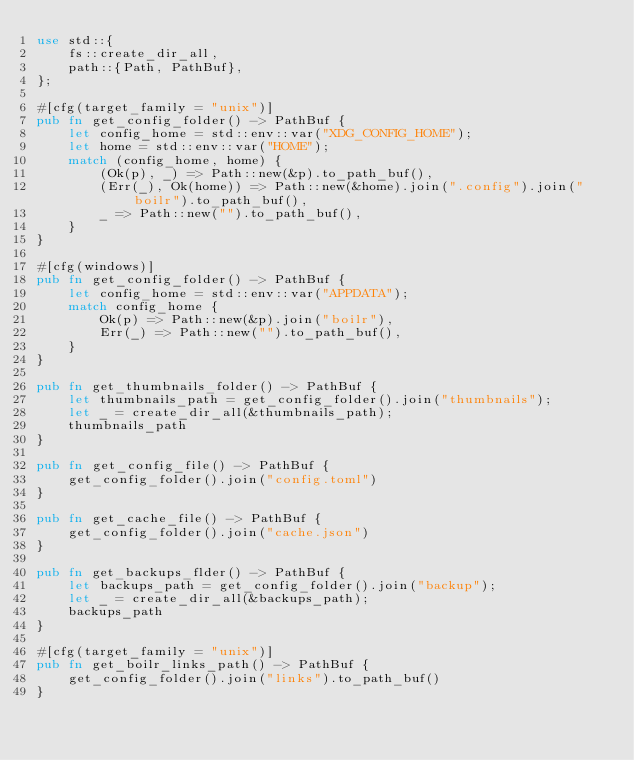Convert code to text. <code><loc_0><loc_0><loc_500><loc_500><_Rust_>use std::{
    fs::create_dir_all,
    path::{Path, PathBuf},
};

#[cfg(target_family = "unix")]
pub fn get_config_folder() -> PathBuf {
    let config_home = std::env::var("XDG_CONFIG_HOME");
    let home = std::env::var("HOME");
    match (config_home, home) {
        (Ok(p), _) => Path::new(&p).to_path_buf(),
        (Err(_), Ok(home)) => Path::new(&home).join(".config").join("boilr").to_path_buf(),
        _ => Path::new("").to_path_buf(),
    }
}

#[cfg(windows)]
pub fn get_config_folder() -> PathBuf {
    let config_home = std::env::var("APPDATA");
    match config_home {
        Ok(p) => Path::new(&p).join("boilr"),
        Err(_) => Path::new("").to_path_buf(),
    }
}

pub fn get_thumbnails_folder() -> PathBuf {
    let thumbnails_path = get_config_folder().join("thumbnails");
    let _ = create_dir_all(&thumbnails_path);
    thumbnails_path
}

pub fn get_config_file() -> PathBuf {
    get_config_folder().join("config.toml")
}

pub fn get_cache_file() -> PathBuf {
    get_config_folder().join("cache.json")
}

pub fn get_backups_flder() -> PathBuf {
    let backups_path = get_config_folder().join("backup");
    let _ = create_dir_all(&backups_path);
    backups_path
}

#[cfg(target_family = "unix")]
pub fn get_boilr_links_path() -> PathBuf {
    get_config_folder().join("links").to_path_buf()
}
</code> 